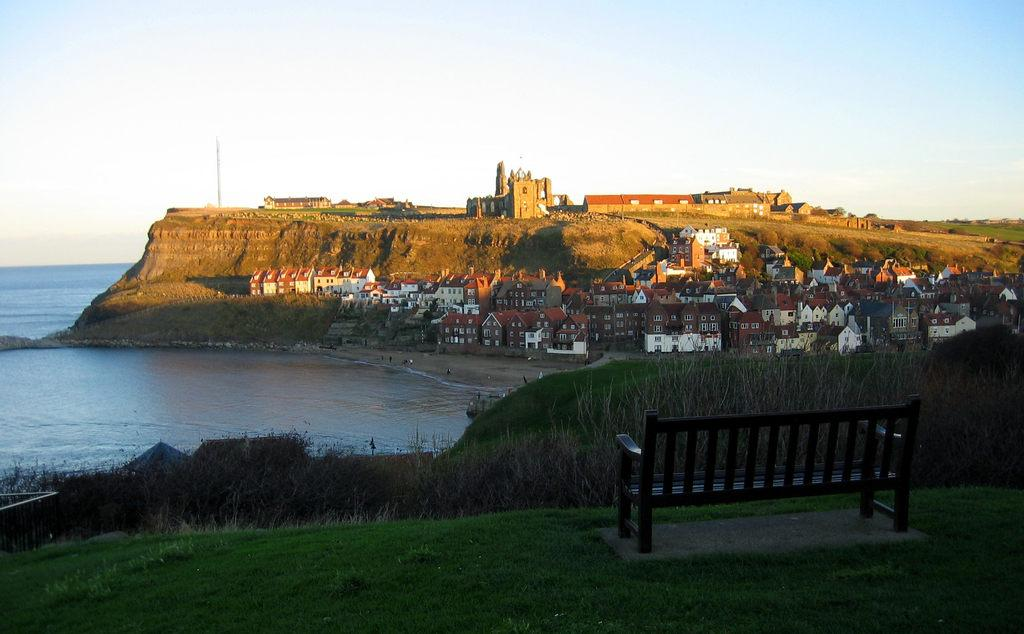What type of surface is on the ground in the image? There is grass on the ground in the image. What type of seating is present in the image? There is a bench in the image. What type of vegetation can be seen in the image? There are plants in the image. What type of structures can be seen in the background of the image? There are buildings in the background of the image. What type of natural feature can be seen in the background of the image? There is a mountain in the background of the image. What part of the natural environment is visible in the background of the image? The sky is visible in the background of the image. Can you tell me how many giraffes are standing near the bench in the image? There are no giraffes present in the image. What type of jewelry is the person wearing in the image? There is no person or jewelry visible in the image. 